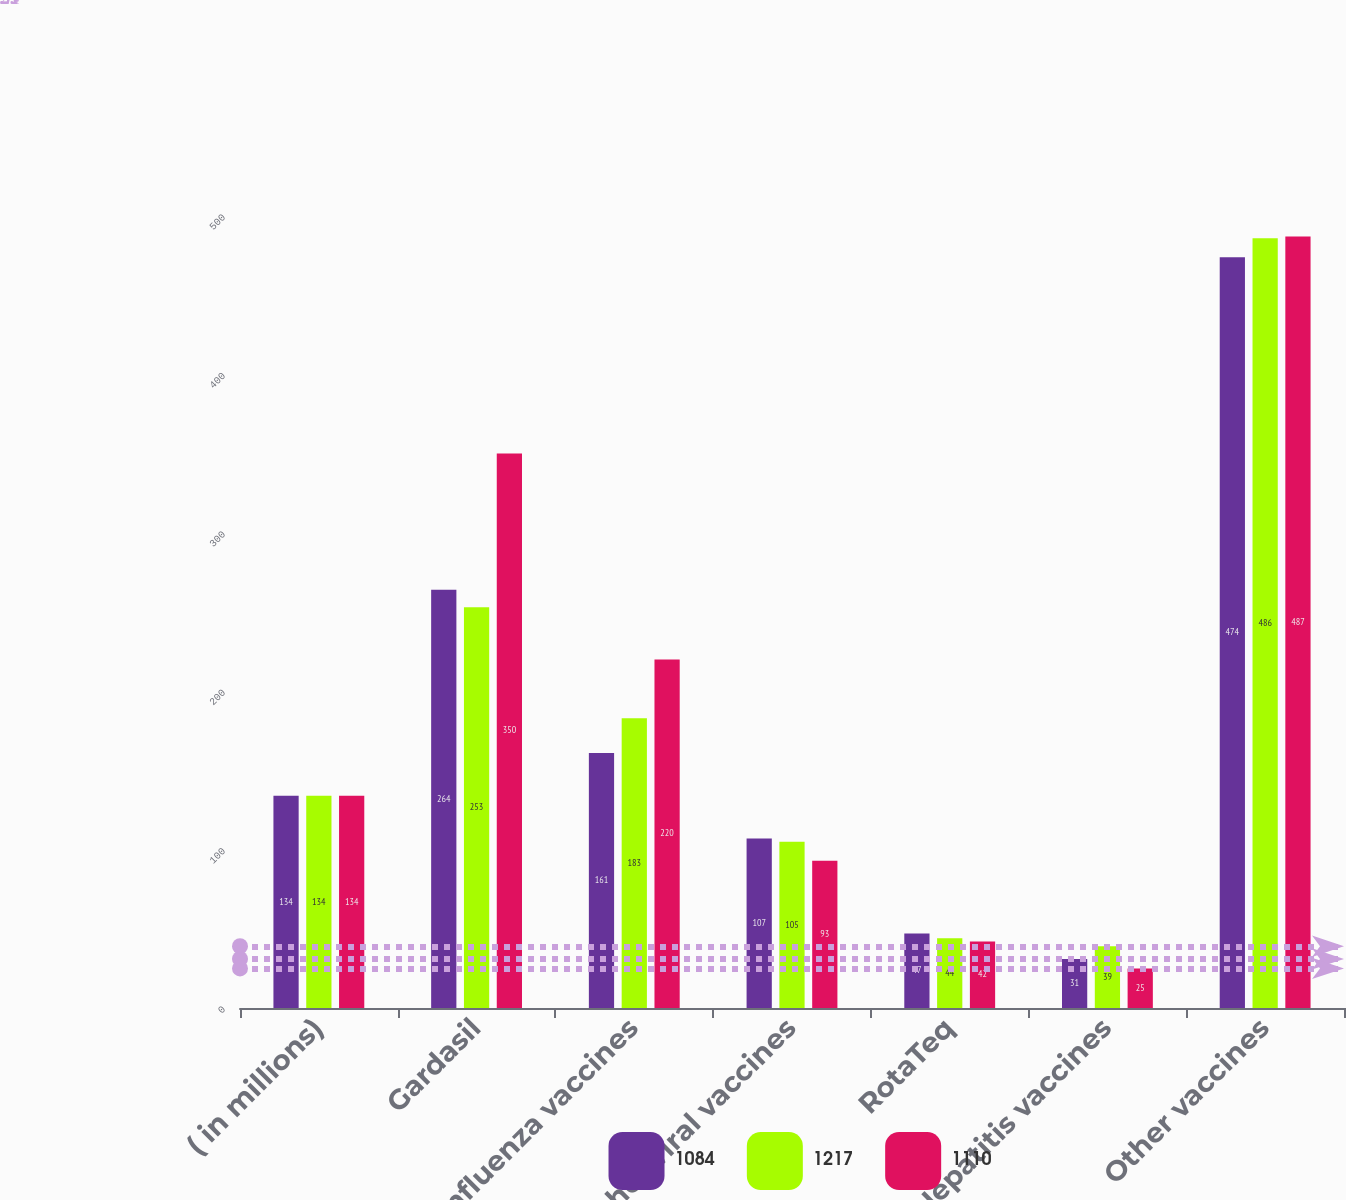<chart> <loc_0><loc_0><loc_500><loc_500><stacked_bar_chart><ecel><fcel>( in millions)<fcel>Gardasil<fcel>Influenza vaccines<fcel>Other viral vaccines<fcel>RotaTeq<fcel>Hepatitis vaccines<fcel>Other vaccines<nl><fcel>1084<fcel>134<fcel>264<fcel>161<fcel>107<fcel>47<fcel>31<fcel>474<nl><fcel>1217<fcel>134<fcel>253<fcel>183<fcel>105<fcel>44<fcel>39<fcel>486<nl><fcel>1110<fcel>134<fcel>350<fcel>220<fcel>93<fcel>42<fcel>25<fcel>487<nl></chart> 